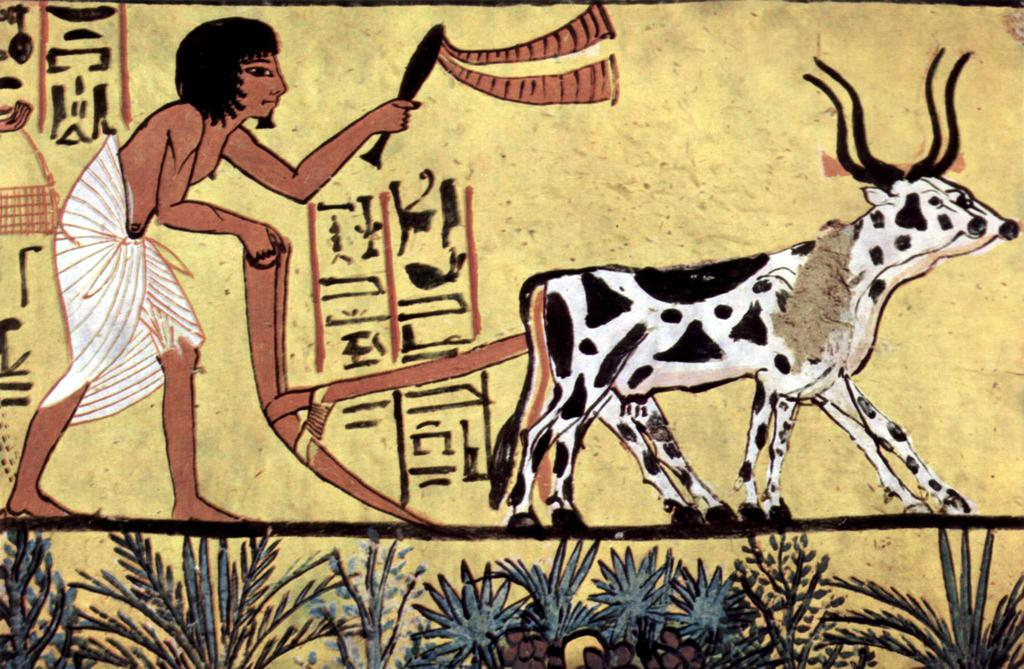What is the main subject of the image? The image contains an art piece. What is the person in the art piece doing? The art piece depicts a person holding a plow and working with animals. What can be seen at the bottom of the image? There are plants at the bottom of the image. What type of thread is being used to create the art piece? There is no information about the materials used to create the art piece in the image. Is there a birthday celebration happening in the art piece? The art piece does not depict a birthday celebration; it shows a person working with animals and holding a plow. 